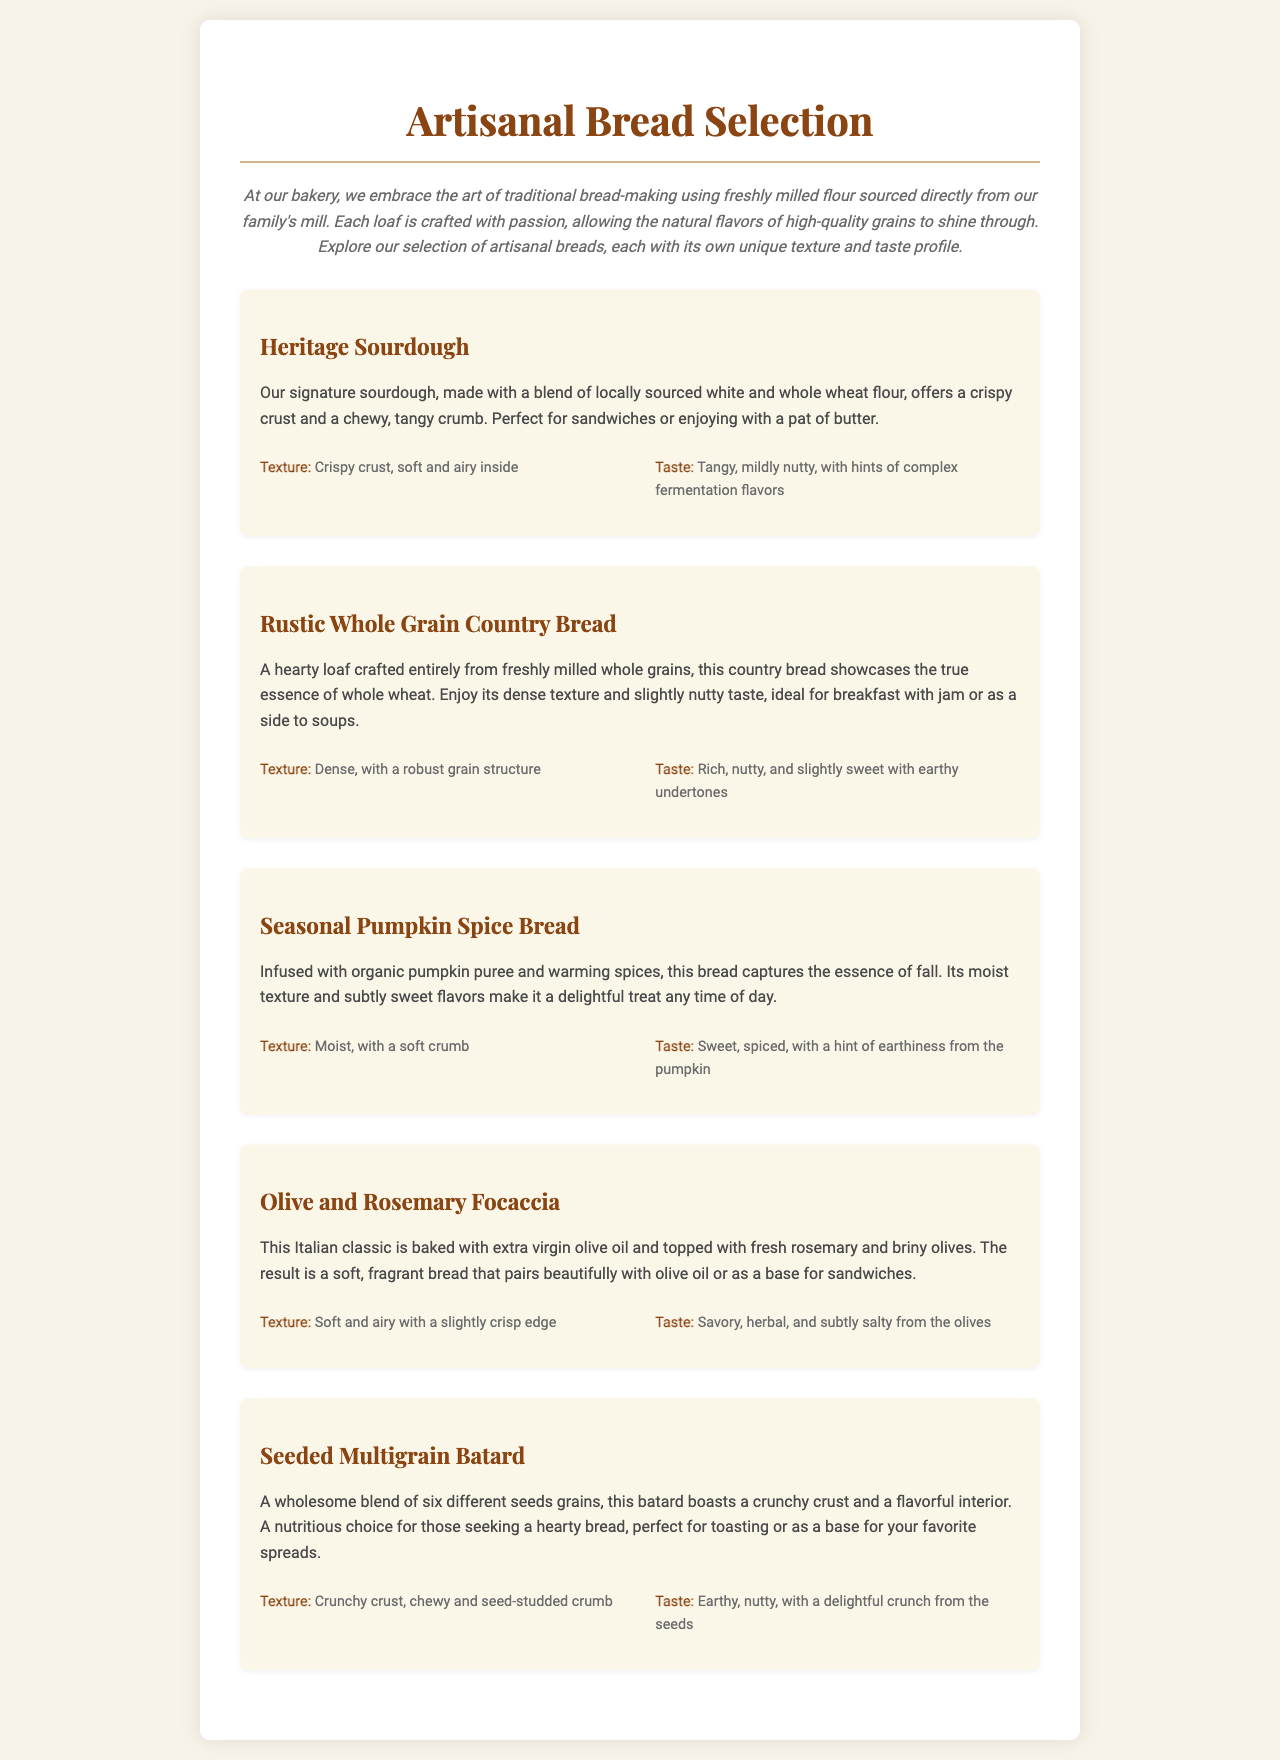What is the first bread listed in the menu? The first bread listed in the menu is the Heritage Sourdough.
Answer: Heritage Sourdough How many different types of bread are showcased in the selection? The selection features five different types of bread.
Answer: Five What flavor is the Seasonal Pumpkin Spice Bread infused with? The Seasonal Pumpkin Spice Bread is infused with organic pumpkin puree.
Answer: Organic pumpkin puree What is the texture description of the Olive and Rosemary Focaccia? The texture description of the Olive and Rosemary Focaccia is soft and airy with a slightly crisp edge.
Answer: Soft and airy with a slightly crisp edge Which bread is crafted entirely from freshly milled whole grains? The Rustic Whole Grain Country Bread is crafted entirely from freshly milled whole grains.
Answer: Rustic Whole Grain Country Bread What flavor profile does the Seeded Multigrain Batard have? The flavor profile of the Seeded Multigrain Batard is earthy, nutty, with a delightful crunch from the seeds.
Answer: Earthy, nutty, with a delightful crunch from the seeds What type of oil is used in the Olive and Rosemary Focaccia? Extra virgin olive oil is used in the Olive and Rosemary Focaccia.
Answer: Extra virgin olive oil What is highlighted about the Heritage Sourdough's taste? The Heritage Sourdough's taste is tangy, mildly nutty, with hints of complex fermentation flavors.
Answer: Tangy, mildly nutty, with hints of complex fermentation flavors 